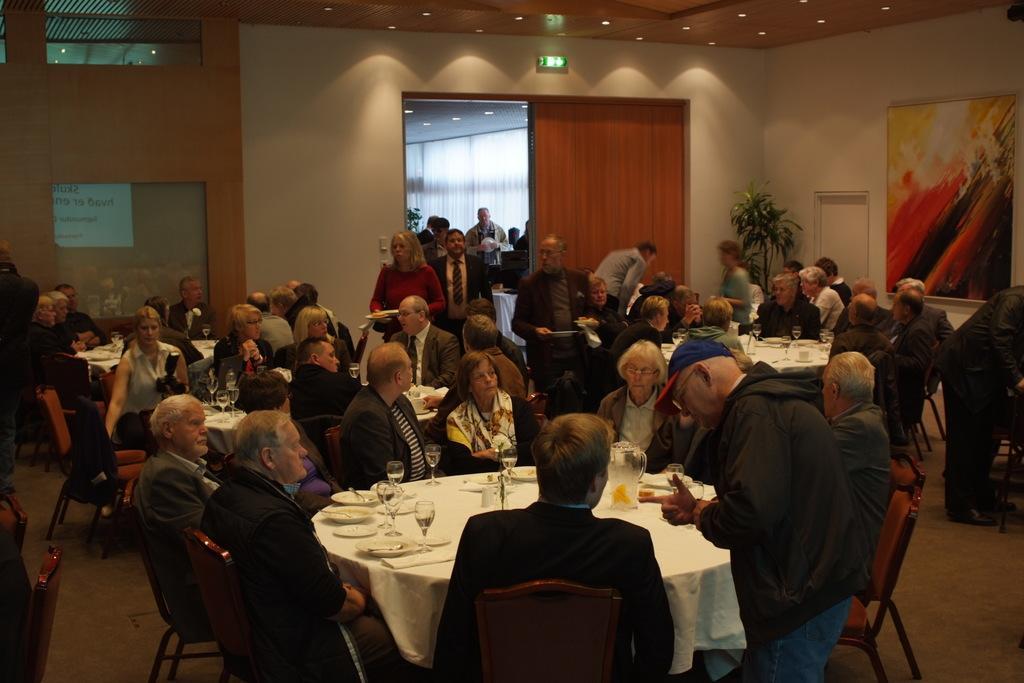Can you describe this image briefly? There are many people in the room. There are tables around it there are chairs. On the table there are plates,glasses. In the background there is a door, there is a plant. On the right side there is painting on the wall. On the top on the ceiling there are lights. 